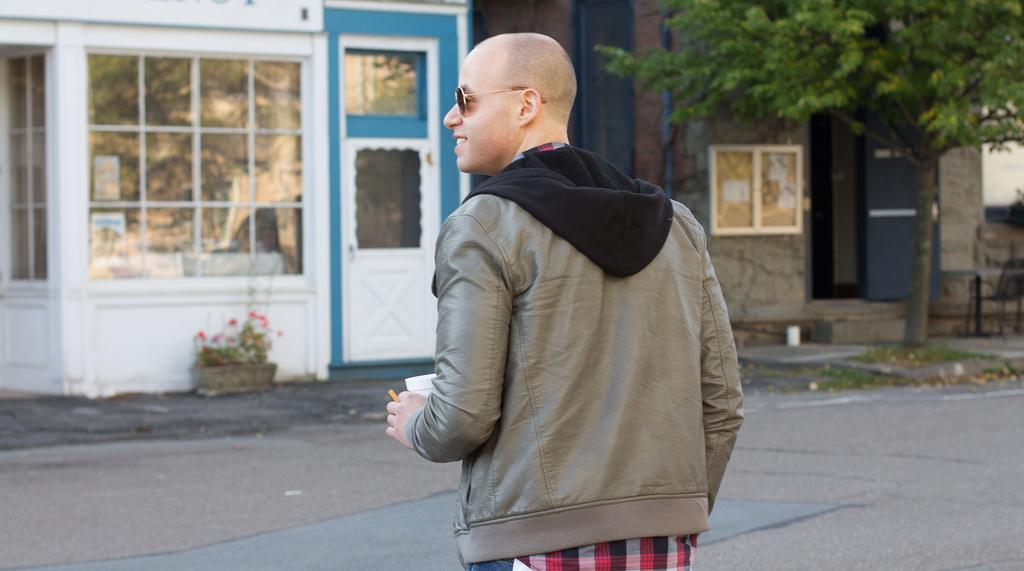What is the person in the image doing? The person is standing in the image. What is the person holding in his hand? The person is holding a juice glass in his hand. What type of clothing is the person wearing? The person is wearing a jacket. What can be seen in the background of the image? There are buildings and a tree visible in the background of the image. What type of belief system does the tree in the background of the image follow? The image does not provide any information about the beliefs of the tree, as it is an inanimate object. 